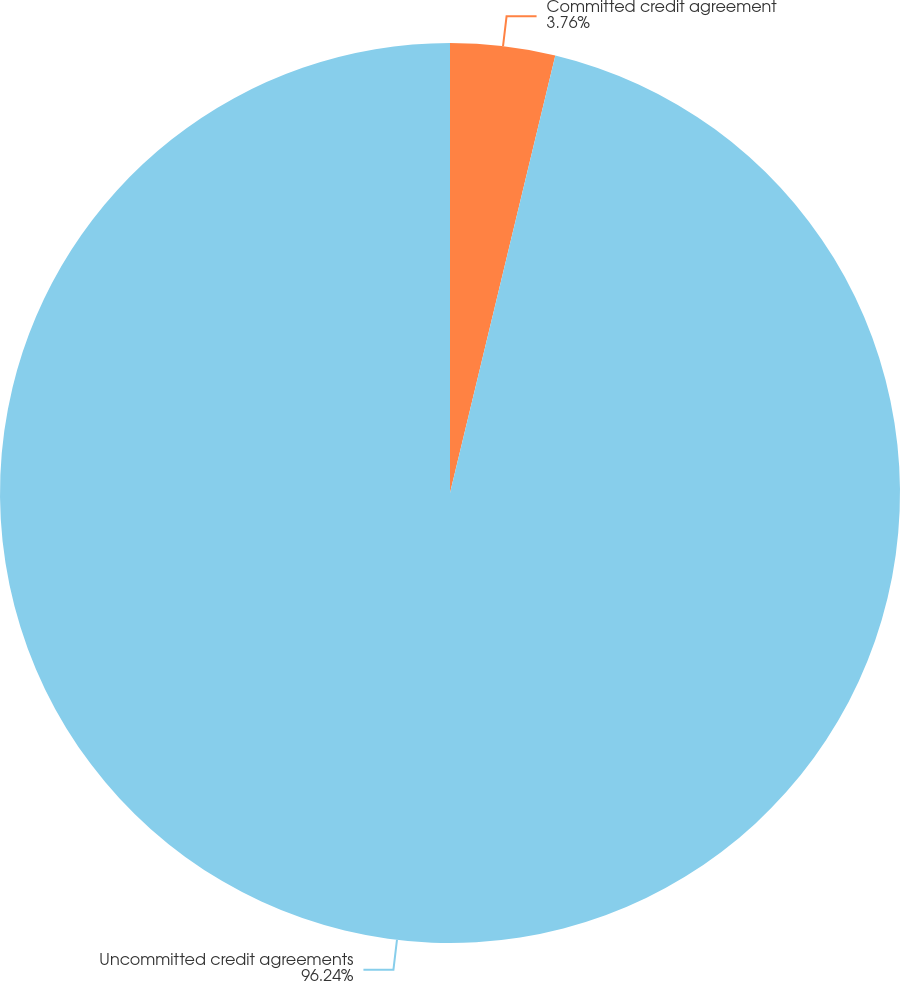Convert chart to OTSL. <chart><loc_0><loc_0><loc_500><loc_500><pie_chart><fcel>Committed credit agreement<fcel>Uncommitted credit agreements<nl><fcel>3.76%<fcel>96.24%<nl></chart> 